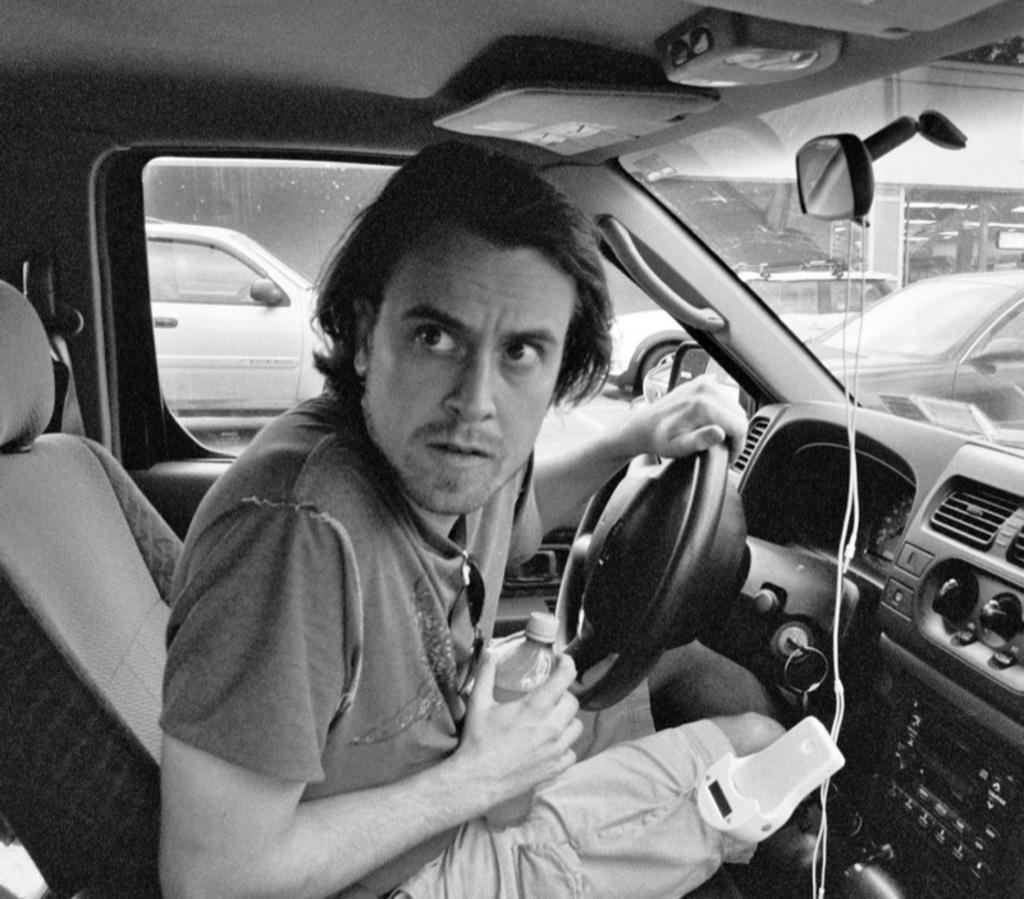What is the man in the image doing? The man is in the driver's position in the car. What is the weather like outside the car? It appears to be raining outside the car. How many cars can be seen on the road in the image? There are many cars on the road. What type of sheet is being used to respect the rain in the image? There is no sheet present in the image, and the rain is not being respected in any way. 